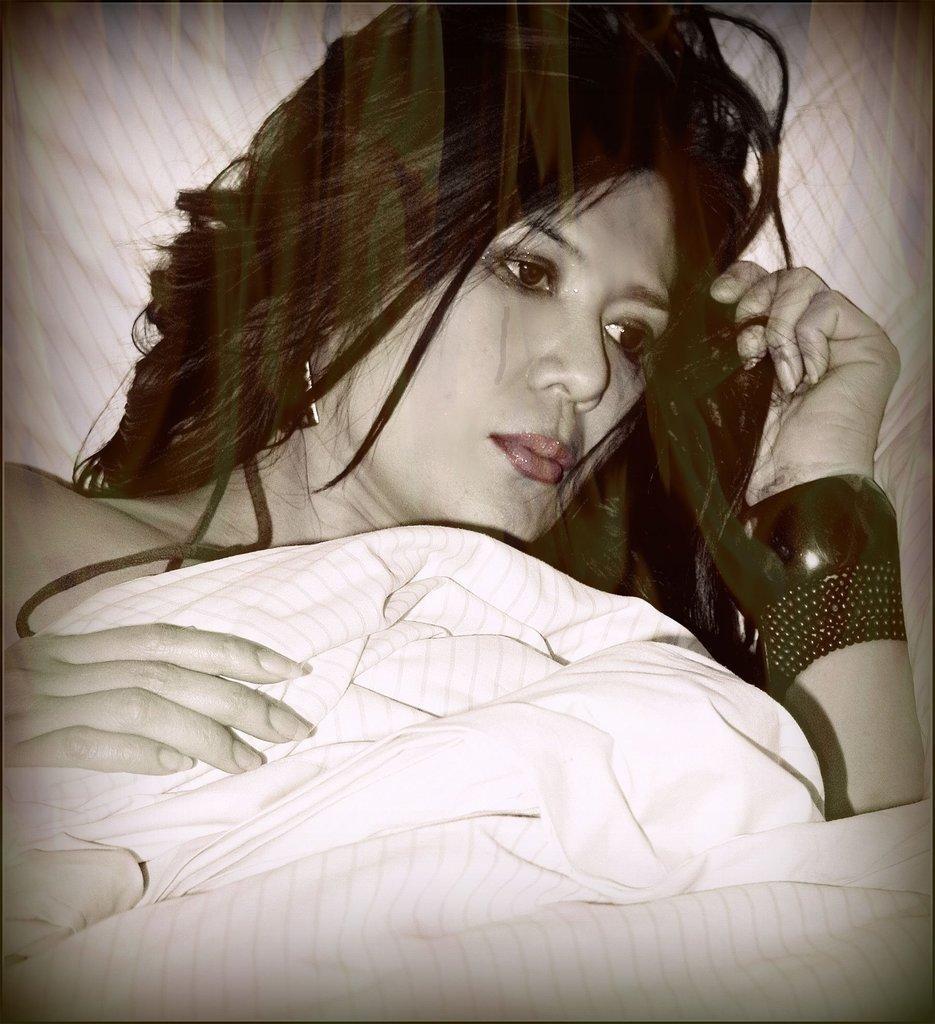How would you summarize this image in a sentence or two? There is a woman lying on a bed. And covering her body with a bed sheet. 